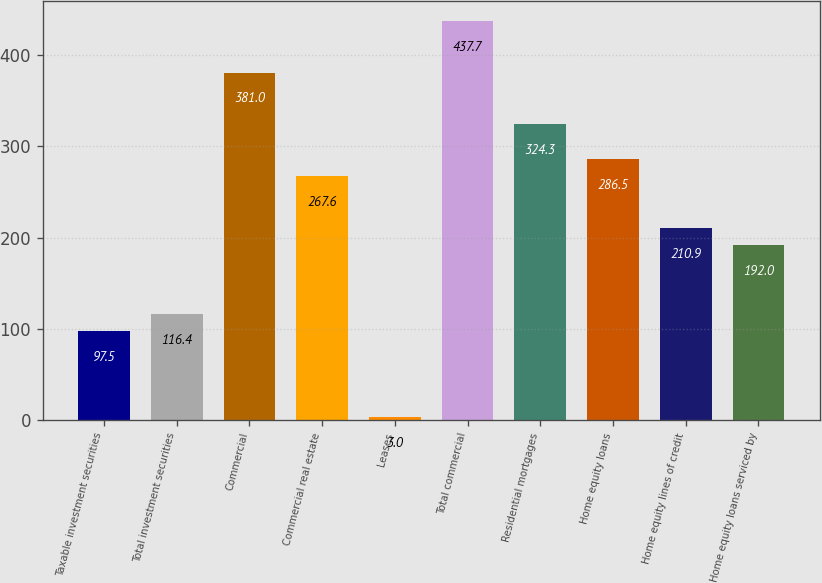<chart> <loc_0><loc_0><loc_500><loc_500><bar_chart><fcel>Taxable investment securities<fcel>Total investment securities<fcel>Commercial<fcel>Commercial real estate<fcel>Leases<fcel>Total commercial<fcel>Residential mortgages<fcel>Home equity loans<fcel>Home equity lines of credit<fcel>Home equity loans serviced by<nl><fcel>97.5<fcel>116.4<fcel>381<fcel>267.6<fcel>3<fcel>437.7<fcel>324.3<fcel>286.5<fcel>210.9<fcel>192<nl></chart> 